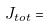Convert formula to latex. <formula><loc_0><loc_0><loc_500><loc_500>J _ { t o t } =</formula> 